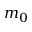<formula> <loc_0><loc_0><loc_500><loc_500>m _ { 0 }</formula> 